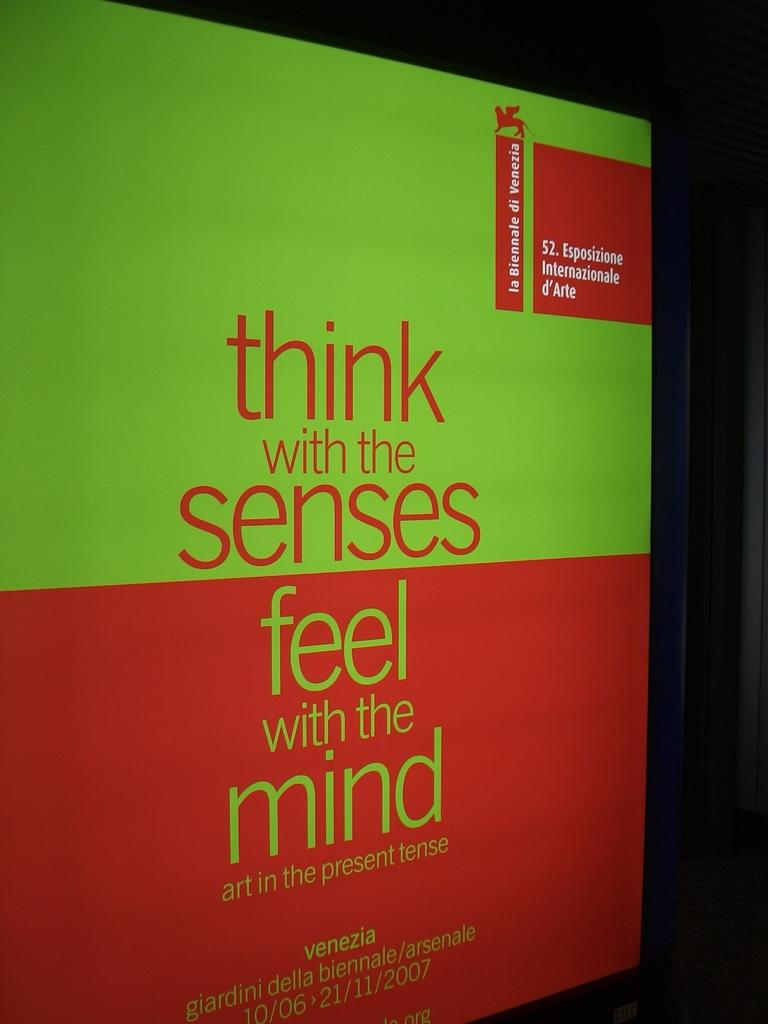Provide a one-sentence caption for the provided image. A sign that says think with the senses feel with the mind. 